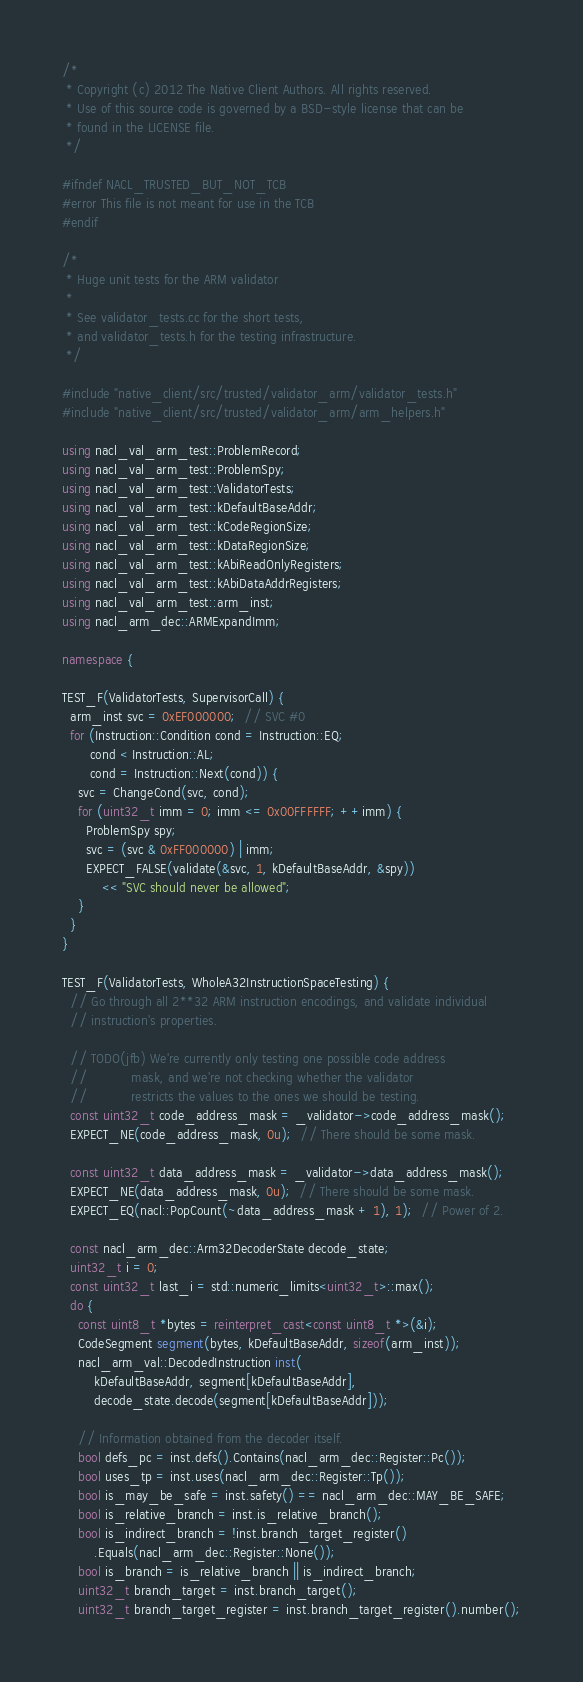Convert code to text. <code><loc_0><loc_0><loc_500><loc_500><_C++_>/*
 * Copyright (c) 2012 The Native Client Authors. All rights reserved.
 * Use of this source code is governed by a BSD-style license that can be
 * found in the LICENSE file.
 */

#ifndef NACL_TRUSTED_BUT_NOT_TCB
#error This file is not meant for use in the TCB
#endif

/*
 * Huge unit tests for the ARM validator
 *
 * See validator_tests.cc for the short tests,
 * and validator_tests.h for the testing infrastructure.
 */

#include "native_client/src/trusted/validator_arm/validator_tests.h"
#include "native_client/src/trusted/validator_arm/arm_helpers.h"

using nacl_val_arm_test::ProblemRecord;
using nacl_val_arm_test::ProblemSpy;
using nacl_val_arm_test::ValidatorTests;
using nacl_val_arm_test::kDefaultBaseAddr;
using nacl_val_arm_test::kCodeRegionSize;
using nacl_val_arm_test::kDataRegionSize;
using nacl_val_arm_test::kAbiReadOnlyRegisters;
using nacl_val_arm_test::kAbiDataAddrRegisters;
using nacl_val_arm_test::arm_inst;
using nacl_arm_dec::ARMExpandImm;

namespace {

TEST_F(ValidatorTests, SupervisorCall) {
  arm_inst svc = 0xEF000000;  // SVC #0
  for (Instruction::Condition cond = Instruction::EQ;
       cond < Instruction::AL;
       cond = Instruction::Next(cond)) {
    svc = ChangeCond(svc, cond);
    for (uint32_t imm = 0; imm <= 0x00FFFFFF; ++imm) {
      ProblemSpy spy;
      svc = (svc & 0xFF000000) | imm;
      EXPECT_FALSE(validate(&svc, 1, kDefaultBaseAddr, &spy))
          << "SVC should never be allowed";
    }
  }
}

TEST_F(ValidatorTests, WholeA32InstructionSpaceTesting) {
  // Go through all 2**32 ARM instruction encodings, and validate individual
  // instruction's properties.

  // TODO(jfb) We're currently only testing one possible code address
  //           mask, and we're not checking whether the validator
  //           restricts the values to the ones we should be testing.
  const uint32_t code_address_mask = _validator->code_address_mask();
  EXPECT_NE(code_address_mask, 0u);  // There should be some mask.

  const uint32_t data_address_mask = _validator->data_address_mask();
  EXPECT_NE(data_address_mask, 0u);  // There should be some mask.
  EXPECT_EQ(nacl::PopCount(~data_address_mask + 1), 1);  // Power of 2.

  const nacl_arm_dec::Arm32DecoderState decode_state;
  uint32_t i = 0;
  const uint32_t last_i = std::numeric_limits<uint32_t>::max();
  do {
    const uint8_t *bytes = reinterpret_cast<const uint8_t *>(&i);
    CodeSegment segment(bytes, kDefaultBaseAddr, sizeof(arm_inst));
    nacl_arm_val::DecodedInstruction inst(
        kDefaultBaseAddr, segment[kDefaultBaseAddr],
        decode_state.decode(segment[kDefaultBaseAddr]));

    // Information obtained from the decoder itself.
    bool defs_pc = inst.defs().Contains(nacl_arm_dec::Register::Pc());
    bool uses_tp = inst.uses(nacl_arm_dec::Register::Tp());
    bool is_may_be_safe = inst.safety() == nacl_arm_dec::MAY_BE_SAFE;
    bool is_relative_branch = inst.is_relative_branch();
    bool is_indirect_branch = !inst.branch_target_register()
        .Equals(nacl_arm_dec::Register::None());
    bool is_branch = is_relative_branch || is_indirect_branch;
    uint32_t branch_target = inst.branch_target();
    uint32_t branch_target_register = inst.branch_target_register().number();</code> 